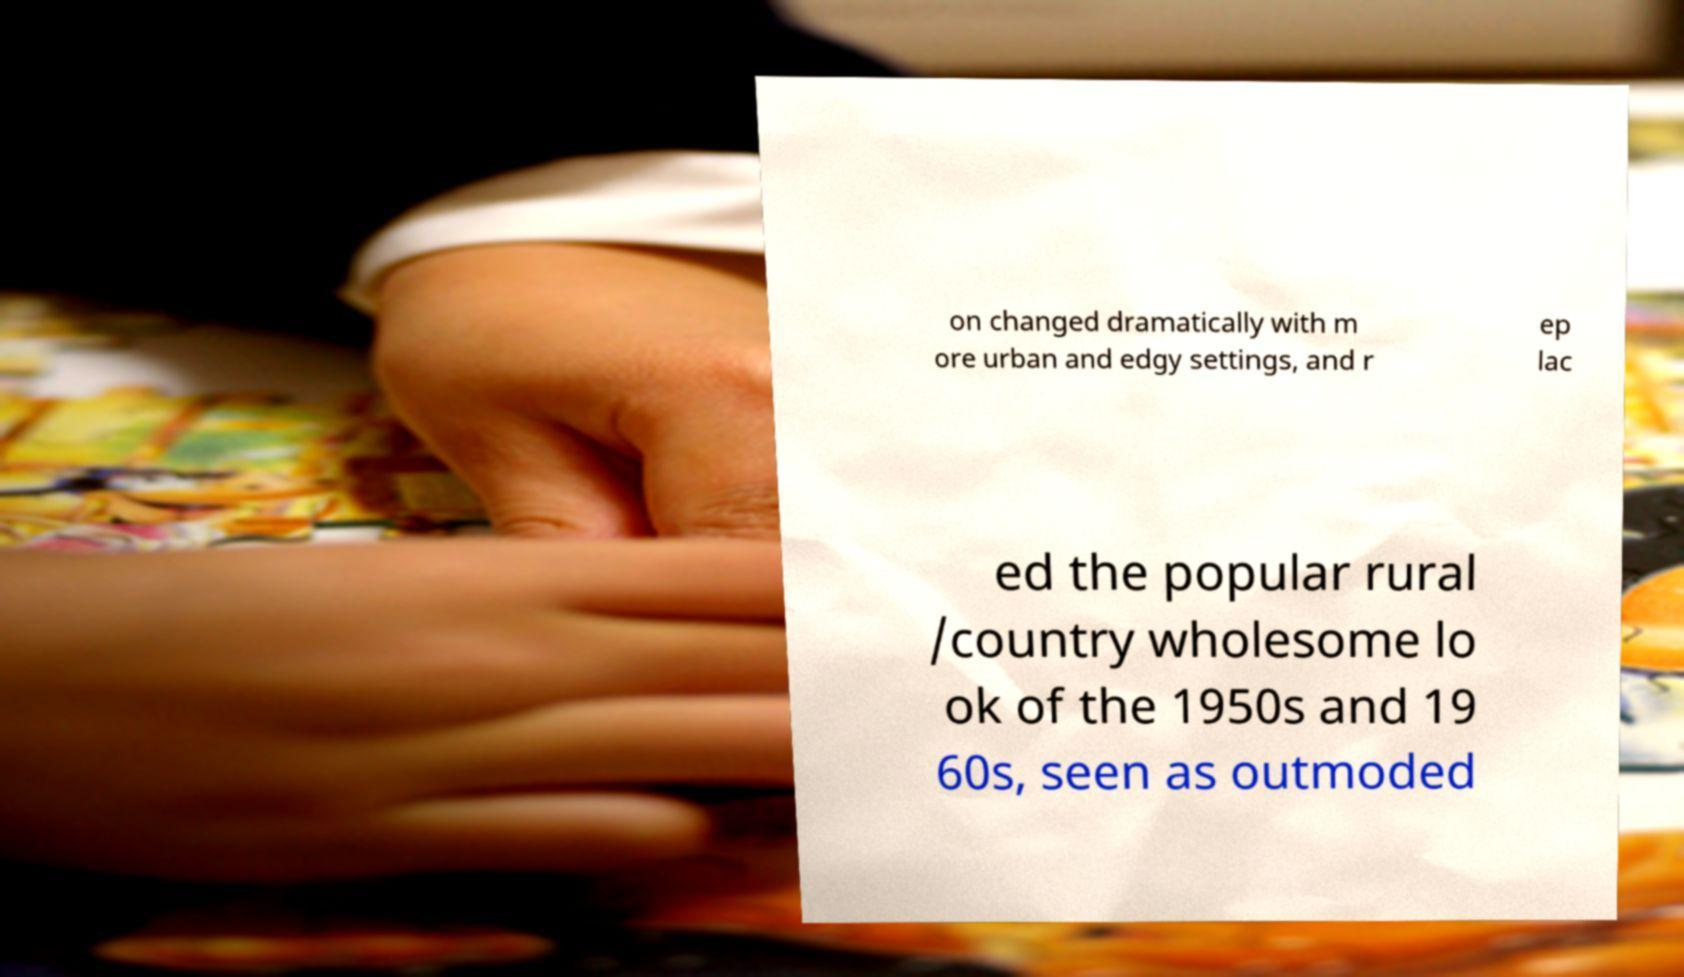I need the written content from this picture converted into text. Can you do that? on changed dramatically with m ore urban and edgy settings, and r ep lac ed the popular rural /country wholesome lo ok of the 1950s and 19 60s, seen as outmoded 